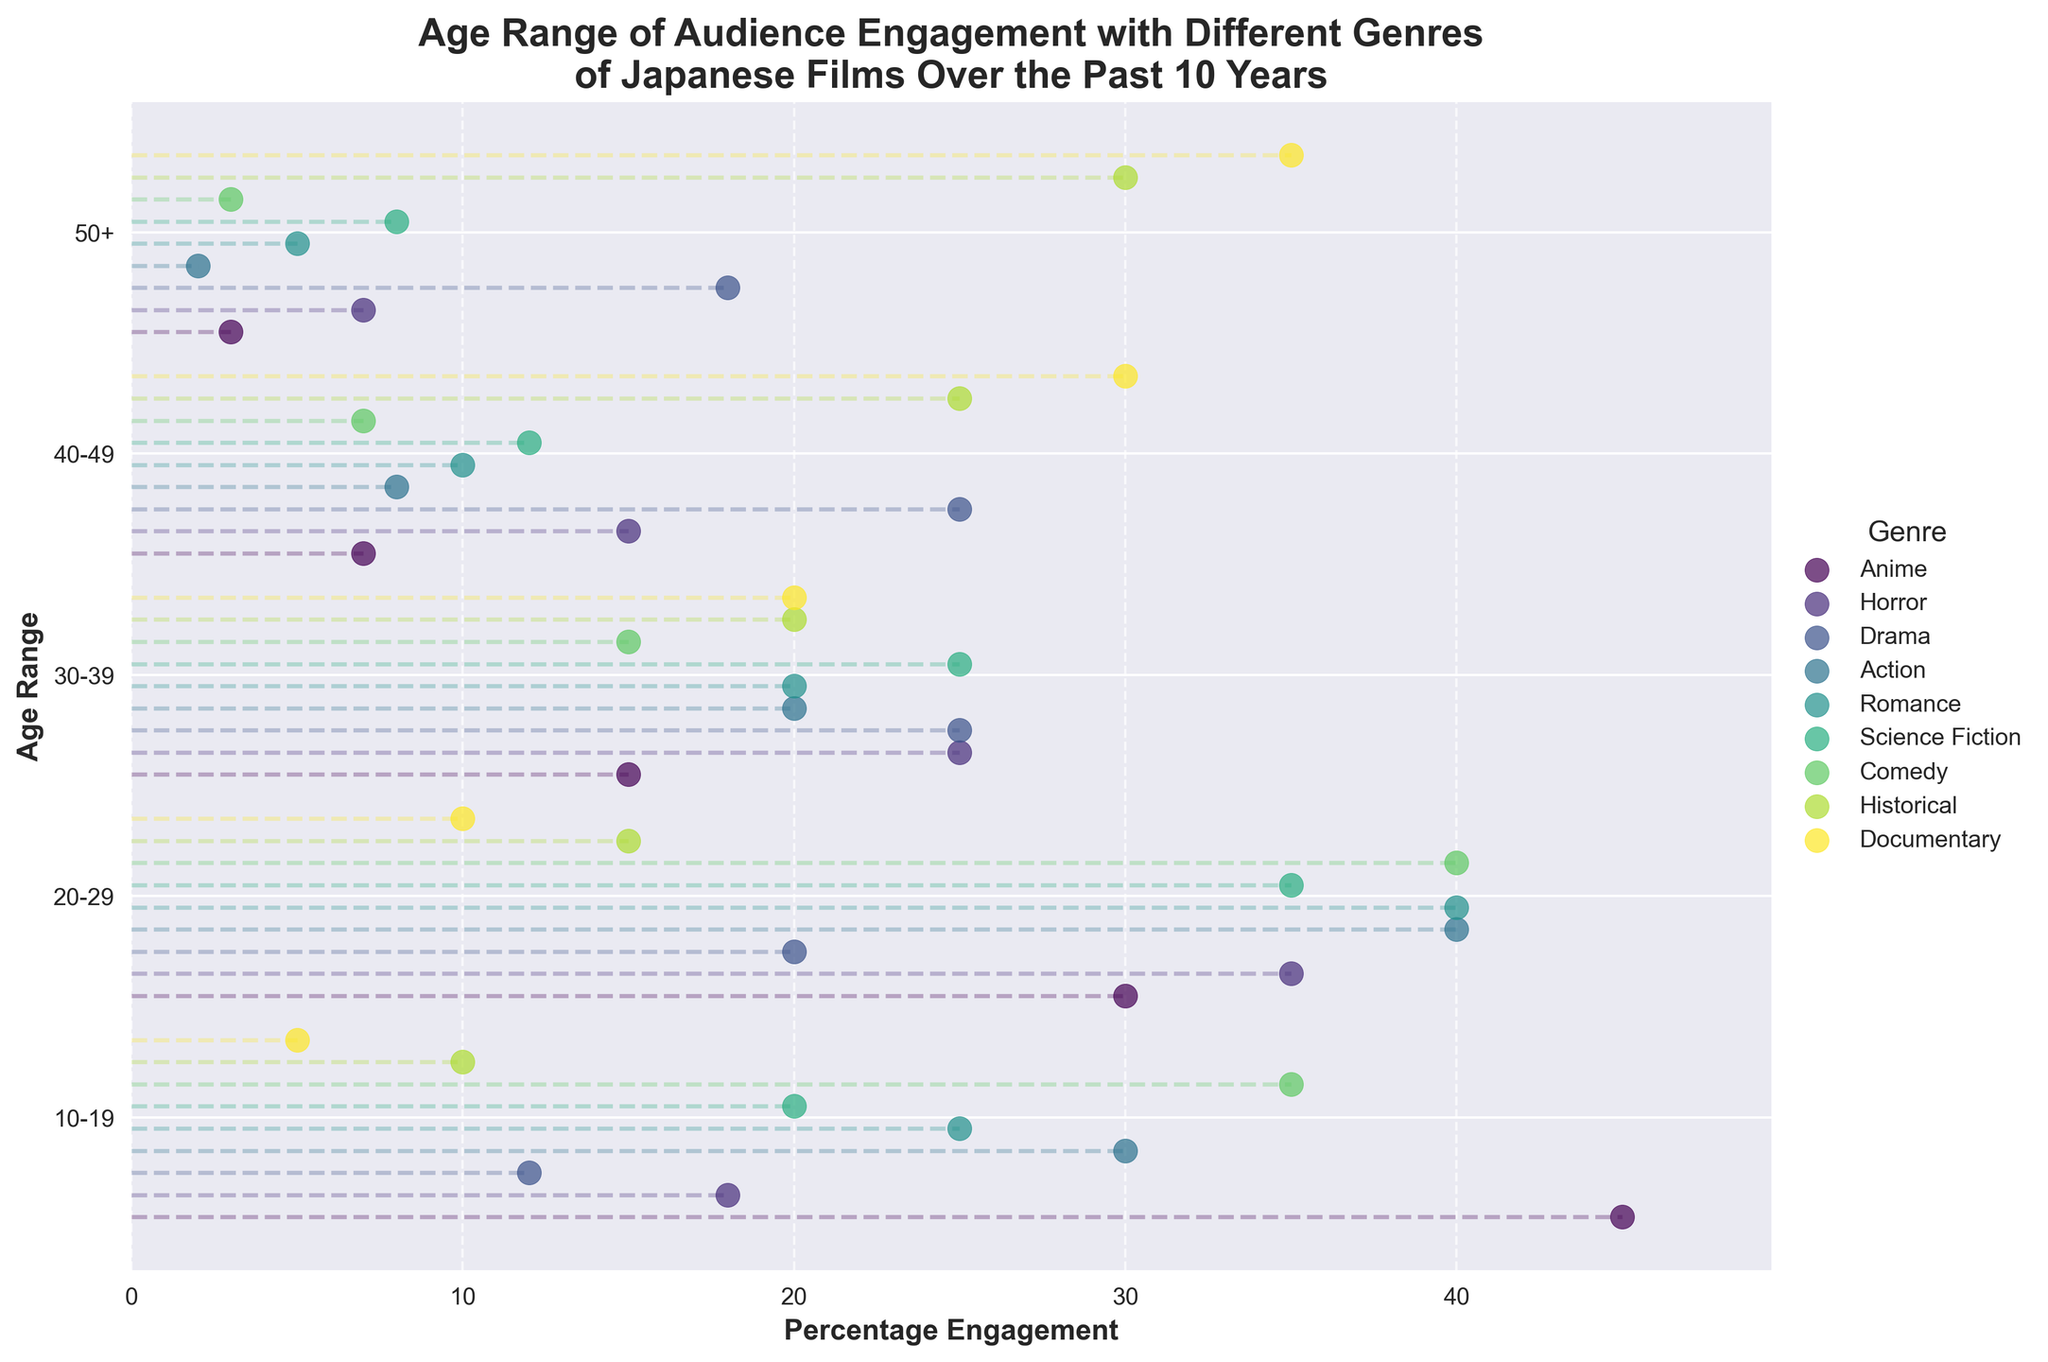What is the title of the ranged dot plot? The title is typically located at the top of the plot, providing context for the visual data. In this case, it reads "Age Range of Audience Engagement with Different Genres of Japanese Films Over the Past 10 Years," indicating what the figure is about.
Answer: Age Range of Audience Engagement with Different Genres of Japanese Films Over the Past 10 Years Which age range has the highest level of engagement with Anime? To find the highest engagement, locate the genre "Anime" and identify the maximum percentage engagement within each age range. The age range "10-19" shows the highest level of engagement at 45%.
Answer: 10-19 How does engagement with Comedy differ between age ranges 10-19 and 50+? Compare the percentage engagement values for Comedy at the age ranges "10-19" and "50+". The engagement for "10-19" is 35%, whereas for "50+" it is 3%. The difference is 35% - 3% = 32%.
Answer: 32 What is the median engagement percentage for Horror films? To find the median, first list the percentage engagements for Horror films: 18, 35, 25, 15, and 7. Order them: 7, 15, 18, 25, 35. The middle value in this ordered list is 18.
Answer: 18 Do Documentary films engage more older age ranges compared to younger ones? To determine this, compare the engagement percentages for younger age ranges (10-19, 20-29) with older age ranges (40-49, 50+). For Documentaries, engagement percentages are 5% (10-19), 10% (20-29), 30% (40-49), and 35% (50+), showing higher engagement levels in older age ranges.
Answer: Yes Which genre has the highest engagement percentage for age 20-29? Look for the highest engagement percentage among the genres for the age range 20-29. Comedy, Romance, Action, and Horror all have the highest engagement at 40%.
Answer: Comedy, Romance, Action, Horror Compare the engagement of Historical films between the youngest and oldest age ranges. Examine the Historical genre's engagement percentages for "10-19" and "50+" age ranges. For "10-19" it is 10%, and for "50+" it is 30%. The percentage for the oldest age range is higher by 30% - 10% = 20%.
Answer: 20 What is the range of engagement for Action films across all age ranges? Find the minimum and maximum percentages for Action films. The minimum is 2% (50+), and the maximum is 40% (20-29). The range is 40% - 2% = 38%.
Answer: 38 Which age range shows the least interest in Drama films? Identify the smallest engagement percentage for Drama across all age ranges. The "10-19" age range has the lowest engagement at 12%.
Answer: 10-19 Which genre has the most even engagement distribution across all age ranges? To determine even distribution, look for genres with percentages closest to each other. Drama and Science Fiction have close percentages across ranges (10-25%). Ultimately, check exact differences. Drama is more even (12%, 20%, 25%, 25%, 18%).
Answer: Drama 